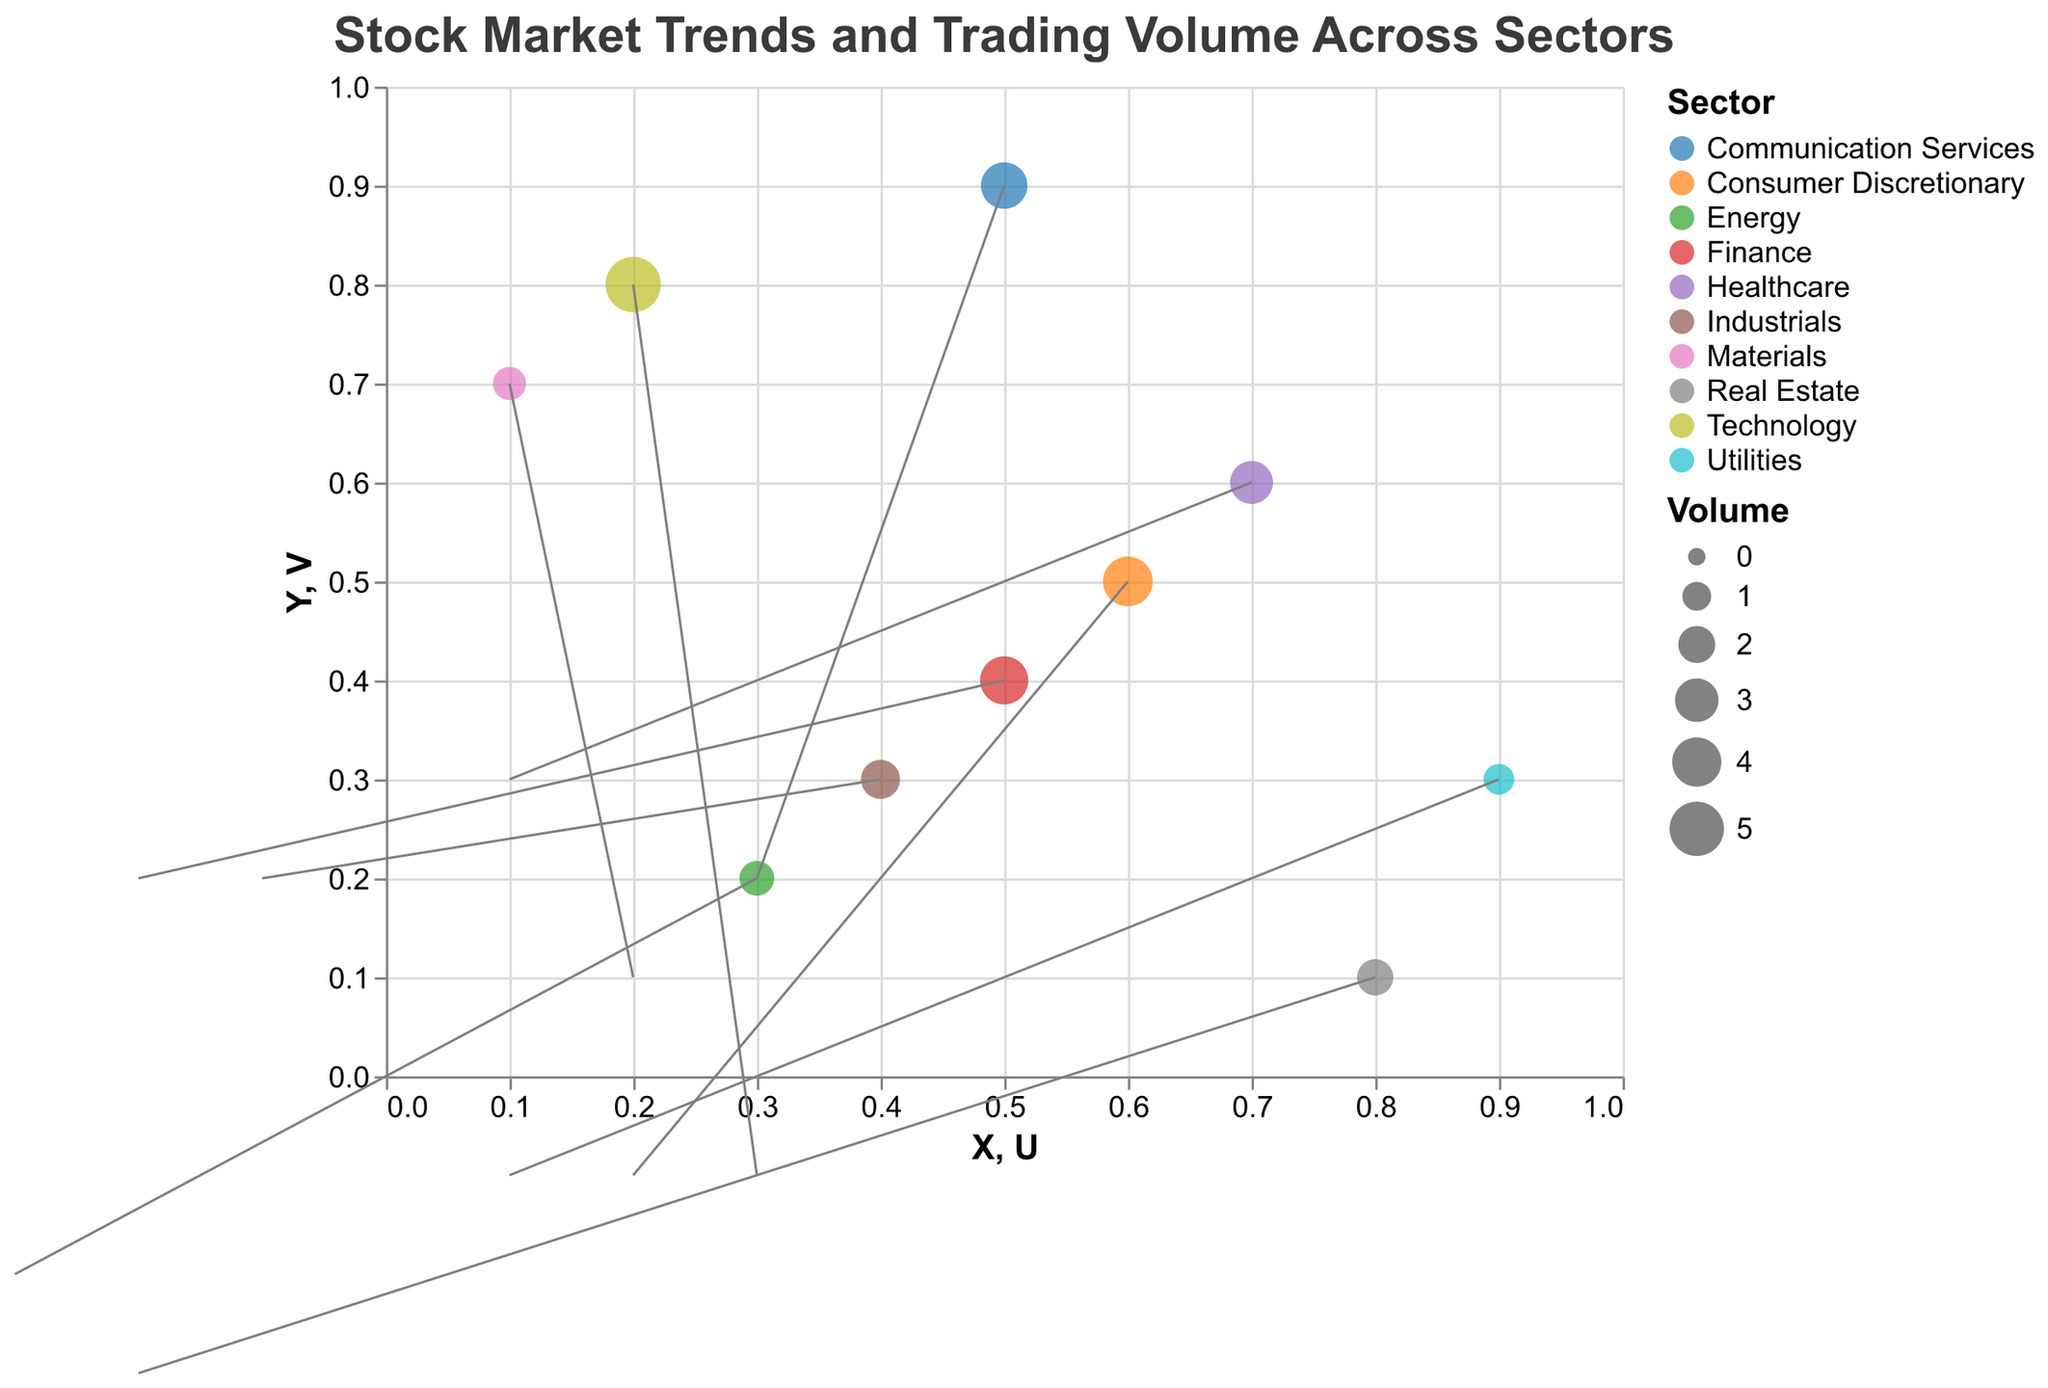What's the title of the plot? The title is displayed at the top of the plot and indicates what the visual represents.
Answer: Stock Market Trends and Trading Volume Across Sectors Which sector has the largest trading volume? The size of the data points represents the trading volume; the largest point indicates the highest volume.
Answer: Technology What are the X and Y coordinates for the Finance sector? Locate the point labeled "Finance" and read the corresponding X and Y values.
Answer: X: 0.5, Y: 0.4 Which sectors have a positive 'U' vector value? Look for sectors where the U component is greater than 0.
Answer: Technology, Healthcare, Consumer Discretionary, Materials, Utilities, Communication Services What does the direction of the arrows represent in the plot? The arrows indicate the direction and magnitude of changes in stock trends for each sector.
Answer: Changes in stock trends Compare the trading volume of the Energy and Utilities sectors. Which one is higher? Compare the sizes of the points representing the Energy and Utilities sectors; the larger point has a higher trading volume.
Answer: Energy Which sector shows a downward trend in the Y-axis and X-axis both? Determine which sector has negative values for both U and V.
Answer: Real Estate What is the volume for the sector with coordinates (0.6, 0.5)? Locate the point at those coordinates and identify the corresponding volume.
Answer: 4.1 If the sector 'Technology' has the highest trading volume, which sector has the second highest? Identify the sector with the next largest point after Technology's largest one.
Answer: Consumer Discretionary How many sectors show an upward trend in the Y direction? Count the number of sectors where the V component is positive.
Answer: Four sectors (Finance, Healthcare, Industrials, Communication Services) 